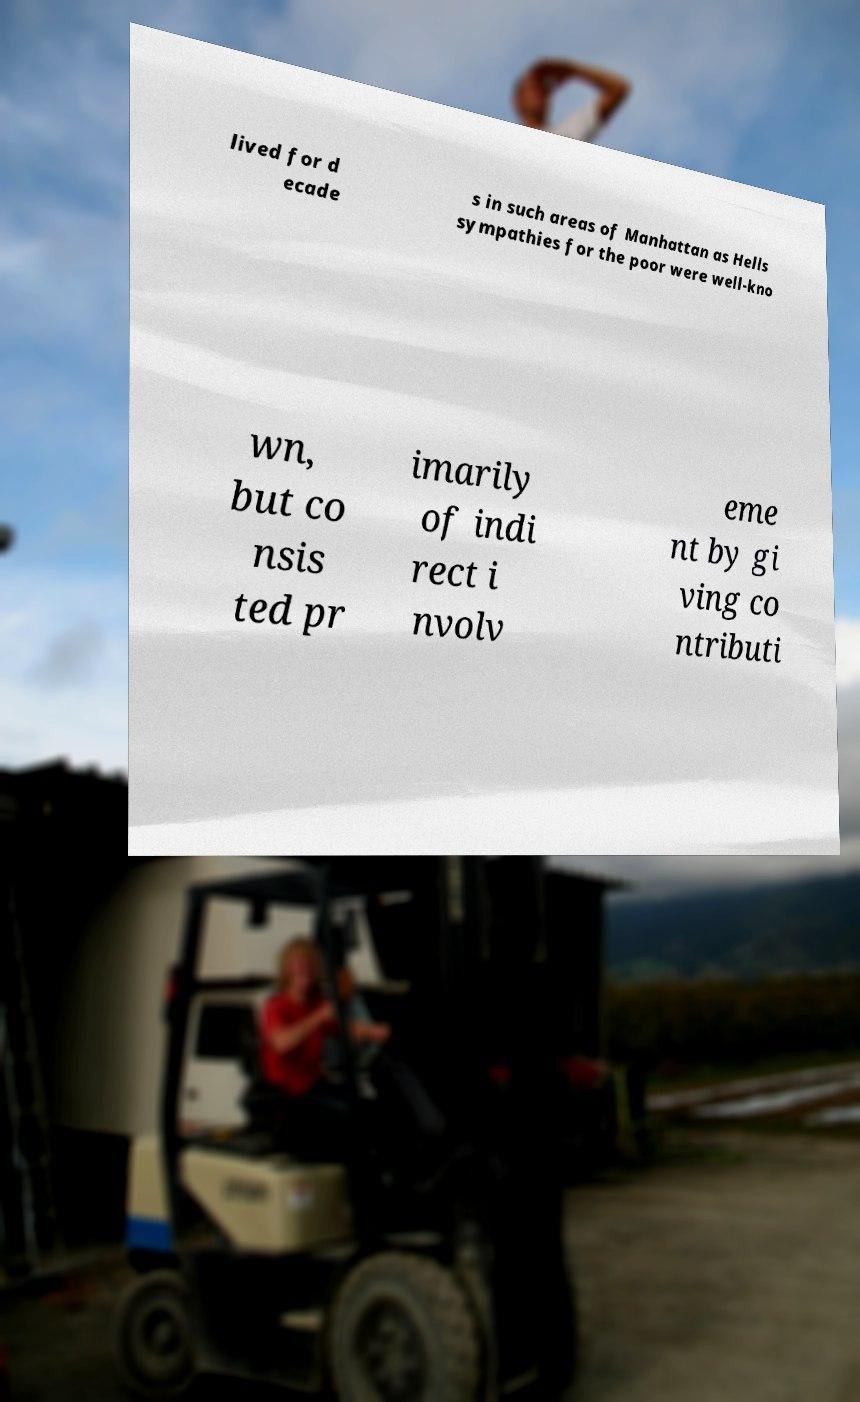There's text embedded in this image that I need extracted. Can you transcribe it verbatim? lived for d ecade s in such areas of Manhattan as Hells sympathies for the poor were well-kno wn, but co nsis ted pr imarily of indi rect i nvolv eme nt by gi ving co ntributi 